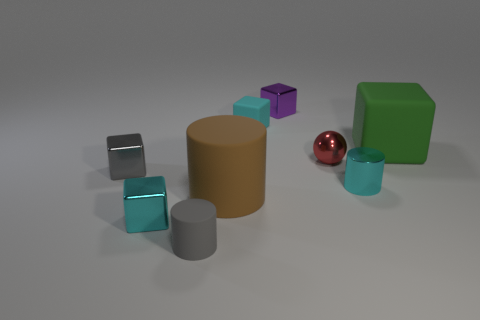Subtract all cyan cylinders. Subtract all green spheres. How many cylinders are left? 2 Add 1 big yellow shiny objects. How many objects exist? 10 Subtract all cylinders. How many objects are left? 6 Add 9 big cylinders. How many big cylinders are left? 10 Add 1 large brown cylinders. How many large brown cylinders exist? 2 Subtract 0 yellow balls. How many objects are left? 9 Subtract all big green shiny objects. Subtract all small purple blocks. How many objects are left? 8 